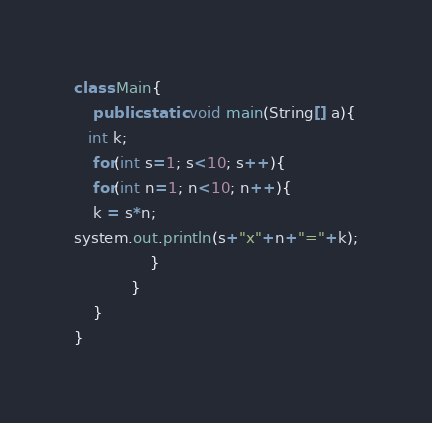<code> <loc_0><loc_0><loc_500><loc_500><_Java_>class Main{
    public static void main(String[] a){
   int k;
    for(int s=1; s<10; s++){
    for(int n=1; n<10; n++){
    k = s*n;
system.out.println(s+"x"+n+"="+k);
                }
            }
    }
}</code> 